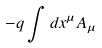Convert formula to latex. <formula><loc_0><loc_0><loc_500><loc_500>- q \int d x ^ { \mu } A _ { \mu }</formula> 